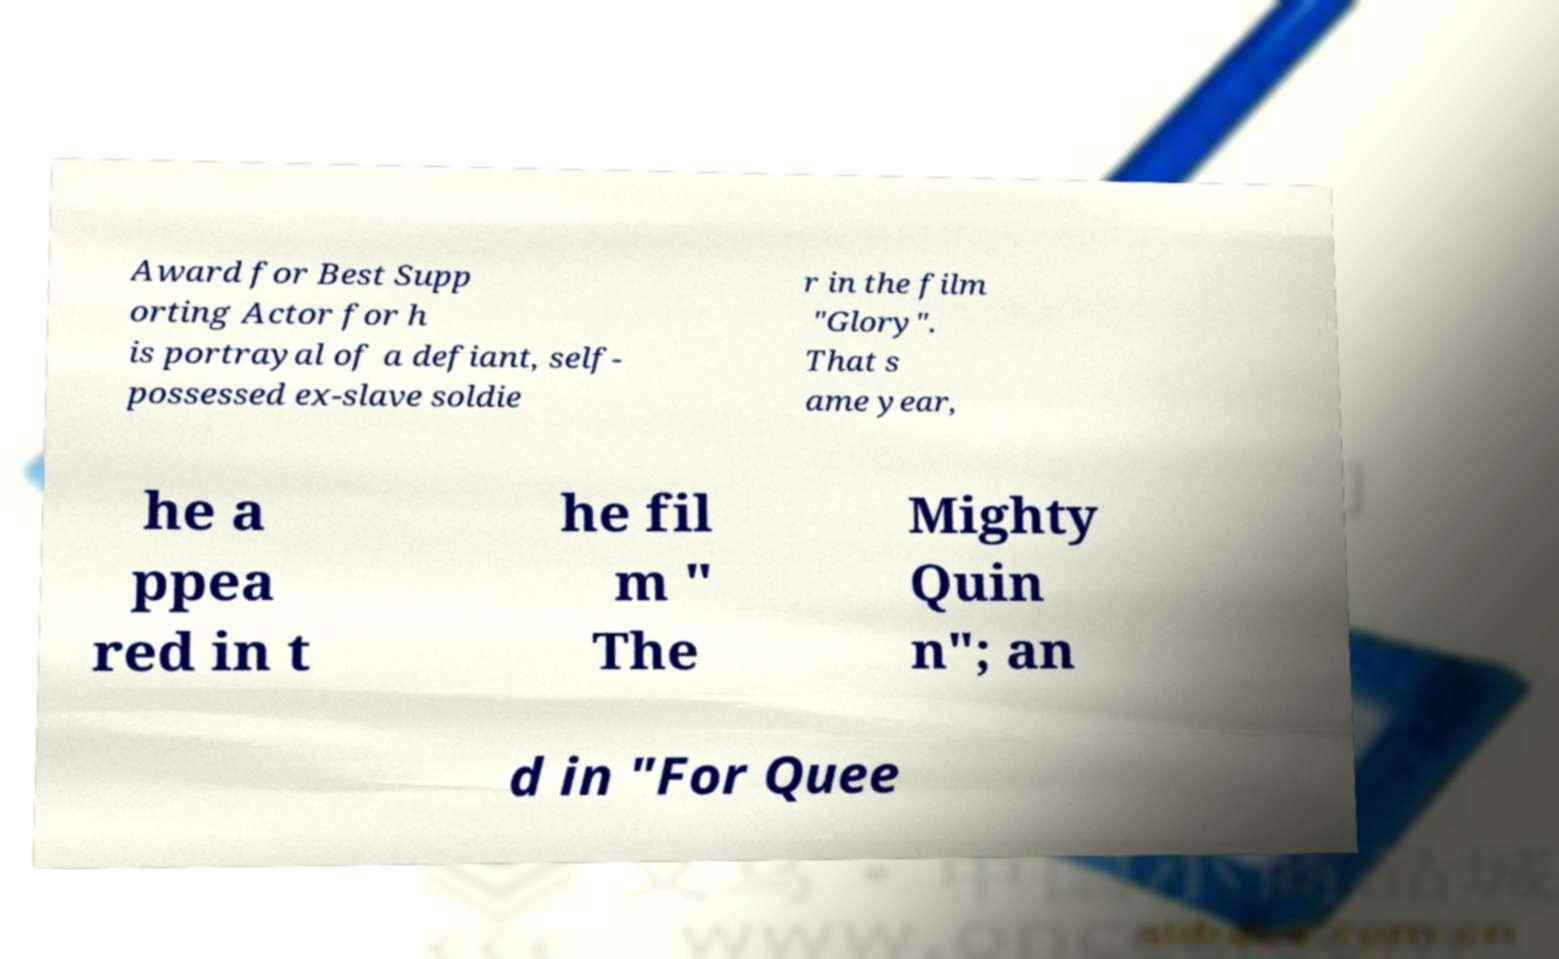Can you accurately transcribe the text from the provided image for me? Award for Best Supp orting Actor for h is portrayal of a defiant, self- possessed ex-slave soldie r in the film "Glory". That s ame year, he a ppea red in t he fil m " The Mighty Quin n"; an d in "For Quee 